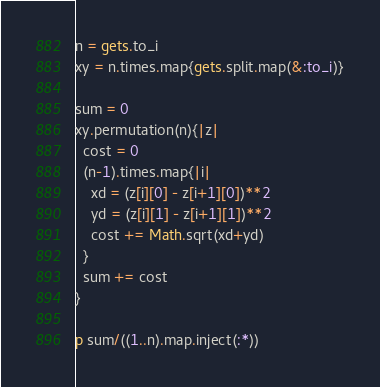Convert code to text. <code><loc_0><loc_0><loc_500><loc_500><_Ruby_>n = gets.to_i
xy = n.times.map{gets.split.map(&:to_i)}

sum = 0
xy.permutation(n){|z|
  cost = 0
  (n-1).times.map{|i|
    xd = (z[i][0] - z[i+1][0])**2
    yd = (z[i][1] - z[i+1][1])**2
    cost += Math.sqrt(xd+yd)
  }
  sum += cost
}

p sum/((1..n).map.inject(:*))
</code> 